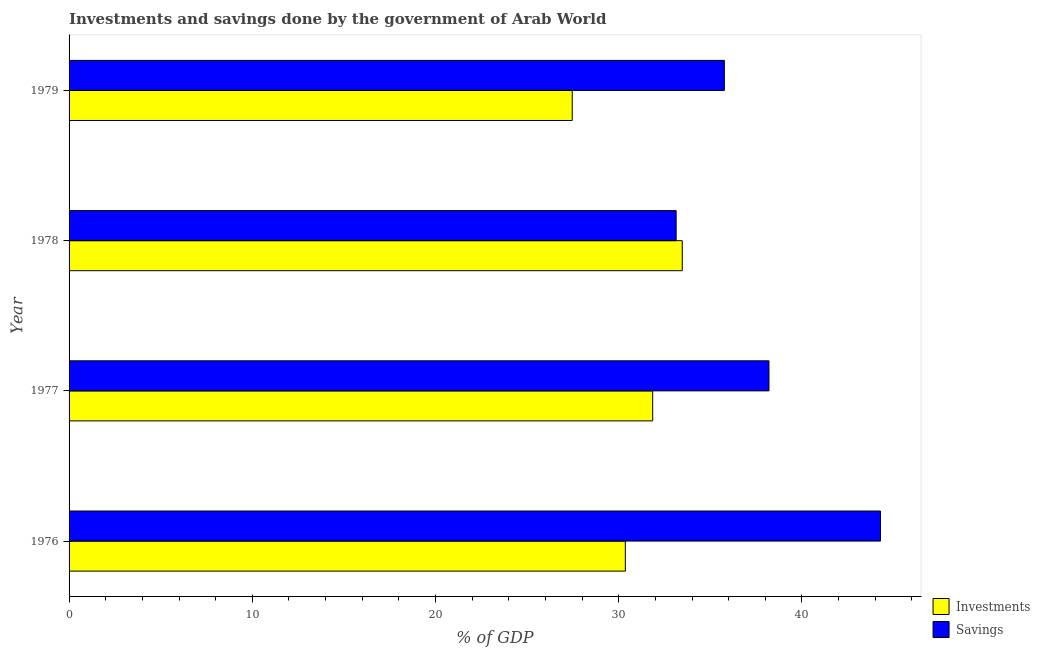How many different coloured bars are there?
Give a very brief answer. 2. How many groups of bars are there?
Provide a succinct answer. 4. Are the number of bars per tick equal to the number of legend labels?
Your answer should be very brief. Yes. How many bars are there on the 3rd tick from the top?
Offer a very short reply. 2. How many bars are there on the 3rd tick from the bottom?
Give a very brief answer. 2. What is the label of the 2nd group of bars from the top?
Your response must be concise. 1978. In how many cases, is the number of bars for a given year not equal to the number of legend labels?
Offer a terse response. 0. What is the investments of government in 1978?
Give a very brief answer. 33.46. Across all years, what is the maximum investments of government?
Provide a succinct answer. 33.46. Across all years, what is the minimum savings of government?
Keep it short and to the point. 33.13. In which year was the savings of government maximum?
Offer a very short reply. 1976. In which year was the savings of government minimum?
Keep it short and to the point. 1978. What is the total investments of government in the graph?
Offer a very short reply. 123.14. What is the difference between the savings of government in 1977 and that in 1978?
Your answer should be very brief. 5.07. What is the difference between the investments of government in 1977 and the savings of government in 1978?
Offer a very short reply. -1.28. What is the average savings of government per year?
Your response must be concise. 37.84. In the year 1976, what is the difference between the investments of government and savings of government?
Your answer should be very brief. -13.92. What is the ratio of the investments of government in 1976 to that in 1979?
Ensure brevity in your answer.  1.11. What is the difference between the highest and the second highest savings of government?
Ensure brevity in your answer.  6.09. What is the difference between the highest and the lowest savings of government?
Your response must be concise. 11.15. In how many years, is the savings of government greater than the average savings of government taken over all years?
Make the answer very short. 2. What does the 1st bar from the top in 1978 represents?
Ensure brevity in your answer.  Savings. What does the 1st bar from the bottom in 1977 represents?
Offer a terse response. Investments. Are all the bars in the graph horizontal?
Offer a very short reply. Yes. What is the difference between two consecutive major ticks on the X-axis?
Your answer should be compact. 10. Are the values on the major ticks of X-axis written in scientific E-notation?
Offer a very short reply. No. Does the graph contain any zero values?
Your answer should be very brief. No. How many legend labels are there?
Your response must be concise. 2. How are the legend labels stacked?
Give a very brief answer. Vertical. What is the title of the graph?
Provide a succinct answer. Investments and savings done by the government of Arab World. Does "Females" appear as one of the legend labels in the graph?
Your answer should be compact. No. What is the label or title of the X-axis?
Ensure brevity in your answer.  % of GDP. What is the % of GDP in Investments in 1976?
Your answer should be very brief. 30.36. What is the % of GDP in Savings in 1976?
Your response must be concise. 44.28. What is the % of GDP in Investments in 1977?
Make the answer very short. 31.85. What is the % of GDP of Savings in 1977?
Keep it short and to the point. 38.2. What is the % of GDP of Investments in 1978?
Provide a succinct answer. 33.46. What is the % of GDP in Savings in 1978?
Make the answer very short. 33.13. What is the % of GDP in Investments in 1979?
Your answer should be compact. 27.46. What is the % of GDP of Savings in 1979?
Offer a terse response. 35.76. Across all years, what is the maximum % of GDP of Investments?
Provide a succinct answer. 33.46. Across all years, what is the maximum % of GDP in Savings?
Offer a terse response. 44.28. Across all years, what is the minimum % of GDP of Investments?
Keep it short and to the point. 27.46. Across all years, what is the minimum % of GDP of Savings?
Your answer should be compact. 33.13. What is the total % of GDP of Investments in the graph?
Make the answer very short. 123.14. What is the total % of GDP of Savings in the graph?
Give a very brief answer. 151.38. What is the difference between the % of GDP in Investments in 1976 and that in 1977?
Your answer should be compact. -1.49. What is the difference between the % of GDP in Savings in 1976 and that in 1977?
Your response must be concise. 6.09. What is the difference between the % of GDP of Investments in 1976 and that in 1978?
Provide a short and direct response. -3.11. What is the difference between the % of GDP in Savings in 1976 and that in 1978?
Your answer should be very brief. 11.15. What is the difference between the % of GDP in Investments in 1976 and that in 1979?
Offer a terse response. 2.9. What is the difference between the % of GDP in Savings in 1976 and that in 1979?
Make the answer very short. 8.52. What is the difference between the % of GDP of Investments in 1977 and that in 1978?
Provide a succinct answer. -1.61. What is the difference between the % of GDP of Savings in 1977 and that in 1978?
Provide a succinct answer. 5.07. What is the difference between the % of GDP in Investments in 1977 and that in 1979?
Give a very brief answer. 4.39. What is the difference between the % of GDP of Savings in 1977 and that in 1979?
Offer a terse response. 2.44. What is the difference between the % of GDP of Investments in 1978 and that in 1979?
Offer a terse response. 6. What is the difference between the % of GDP in Savings in 1978 and that in 1979?
Ensure brevity in your answer.  -2.63. What is the difference between the % of GDP of Investments in 1976 and the % of GDP of Savings in 1977?
Your answer should be compact. -7.84. What is the difference between the % of GDP of Investments in 1976 and the % of GDP of Savings in 1978?
Your answer should be compact. -2.77. What is the difference between the % of GDP of Investments in 1976 and the % of GDP of Savings in 1979?
Keep it short and to the point. -5.4. What is the difference between the % of GDP in Investments in 1977 and the % of GDP in Savings in 1978?
Keep it short and to the point. -1.28. What is the difference between the % of GDP in Investments in 1977 and the % of GDP in Savings in 1979?
Your answer should be very brief. -3.91. What is the difference between the % of GDP in Investments in 1978 and the % of GDP in Savings in 1979?
Ensure brevity in your answer.  -2.3. What is the average % of GDP in Investments per year?
Offer a terse response. 30.78. What is the average % of GDP of Savings per year?
Offer a very short reply. 37.84. In the year 1976, what is the difference between the % of GDP in Investments and % of GDP in Savings?
Provide a succinct answer. -13.92. In the year 1977, what is the difference between the % of GDP of Investments and % of GDP of Savings?
Provide a short and direct response. -6.35. In the year 1978, what is the difference between the % of GDP in Investments and % of GDP in Savings?
Your answer should be compact. 0.33. In the year 1979, what is the difference between the % of GDP in Investments and % of GDP in Savings?
Give a very brief answer. -8.3. What is the ratio of the % of GDP in Investments in 1976 to that in 1977?
Offer a terse response. 0.95. What is the ratio of the % of GDP of Savings in 1976 to that in 1977?
Provide a short and direct response. 1.16. What is the ratio of the % of GDP in Investments in 1976 to that in 1978?
Make the answer very short. 0.91. What is the ratio of the % of GDP of Savings in 1976 to that in 1978?
Provide a short and direct response. 1.34. What is the ratio of the % of GDP in Investments in 1976 to that in 1979?
Give a very brief answer. 1.11. What is the ratio of the % of GDP in Savings in 1976 to that in 1979?
Your answer should be compact. 1.24. What is the ratio of the % of GDP of Investments in 1977 to that in 1978?
Keep it short and to the point. 0.95. What is the ratio of the % of GDP of Savings in 1977 to that in 1978?
Your response must be concise. 1.15. What is the ratio of the % of GDP of Investments in 1977 to that in 1979?
Provide a short and direct response. 1.16. What is the ratio of the % of GDP of Savings in 1977 to that in 1979?
Offer a very short reply. 1.07. What is the ratio of the % of GDP in Investments in 1978 to that in 1979?
Your response must be concise. 1.22. What is the ratio of the % of GDP in Savings in 1978 to that in 1979?
Keep it short and to the point. 0.93. What is the difference between the highest and the second highest % of GDP of Investments?
Your answer should be compact. 1.61. What is the difference between the highest and the second highest % of GDP in Savings?
Provide a succinct answer. 6.09. What is the difference between the highest and the lowest % of GDP of Investments?
Your response must be concise. 6. What is the difference between the highest and the lowest % of GDP in Savings?
Offer a terse response. 11.15. 